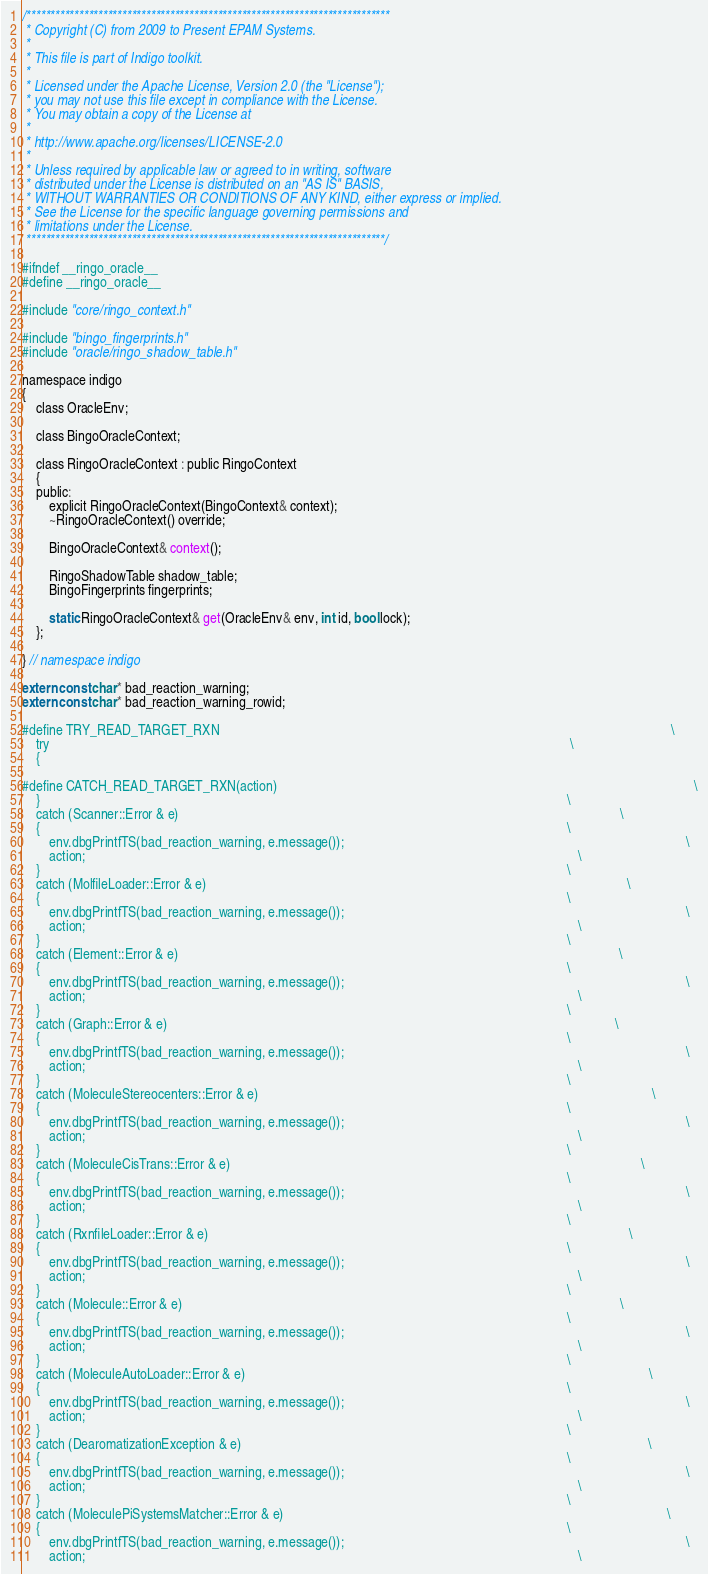<code> <loc_0><loc_0><loc_500><loc_500><_C_>/****************************************************************************
 * Copyright (C) from 2009 to Present EPAM Systems.
 *
 * This file is part of Indigo toolkit.
 *
 * Licensed under the Apache License, Version 2.0 (the "License");
 * you may not use this file except in compliance with the License.
 * You may obtain a copy of the License at
 *
 * http://www.apache.org/licenses/LICENSE-2.0
 *
 * Unless required by applicable law or agreed to in writing, software
 * distributed under the License is distributed on an "AS IS" BASIS,
 * WITHOUT WARRANTIES OR CONDITIONS OF ANY KIND, either express or implied.
 * See the License for the specific language governing permissions and
 * limitations under the License.
 ***************************************************************************/

#ifndef __ringo_oracle__
#define __ringo_oracle__

#include "core/ringo_context.h"

#include "bingo_fingerprints.h"
#include "oracle/ringo_shadow_table.h"

namespace indigo
{
    class OracleEnv;

    class BingoOracleContext;

    class RingoOracleContext : public RingoContext
    {
    public:
        explicit RingoOracleContext(BingoContext& context);
        ~RingoOracleContext() override;

        BingoOracleContext& context();

        RingoShadowTable shadow_table;
        BingoFingerprints fingerprints;

        static RingoOracleContext& get(OracleEnv& env, int id, bool lock);
    };

} // namespace indigo

extern const char* bad_reaction_warning;
extern const char* bad_reaction_warning_rowid;

#define TRY_READ_TARGET_RXN                                                                                                                                    \
    try                                                                                                                                                        \
    {

#define CATCH_READ_TARGET_RXN(action)                                                                                                                          \
    }                                                                                                                                                          \
    catch (Scanner::Error & e)                                                                                                                                 \
    {                                                                                                                                                          \
        env.dbgPrintfTS(bad_reaction_warning, e.message());                                                                                                    \
        action;                                                                                                                                                \
    }                                                                                                                                                          \
    catch (MolfileLoader::Error & e)                                                                                                                           \
    {                                                                                                                                                          \
        env.dbgPrintfTS(bad_reaction_warning, e.message());                                                                                                    \
        action;                                                                                                                                                \
    }                                                                                                                                                          \
    catch (Element::Error & e)                                                                                                                                 \
    {                                                                                                                                                          \
        env.dbgPrintfTS(bad_reaction_warning, e.message());                                                                                                    \
        action;                                                                                                                                                \
    }                                                                                                                                                          \
    catch (Graph::Error & e)                                                                                                                                   \
    {                                                                                                                                                          \
        env.dbgPrintfTS(bad_reaction_warning, e.message());                                                                                                    \
        action;                                                                                                                                                \
    }                                                                                                                                                          \
    catch (MoleculeStereocenters::Error & e)                                                                                                                   \
    {                                                                                                                                                          \
        env.dbgPrintfTS(bad_reaction_warning, e.message());                                                                                                    \
        action;                                                                                                                                                \
    }                                                                                                                                                          \
    catch (MoleculeCisTrans::Error & e)                                                                                                                        \
    {                                                                                                                                                          \
        env.dbgPrintfTS(bad_reaction_warning, e.message());                                                                                                    \
        action;                                                                                                                                                \
    }                                                                                                                                                          \
    catch (RxnfileLoader::Error & e)                                                                                                                           \
    {                                                                                                                                                          \
        env.dbgPrintfTS(bad_reaction_warning, e.message());                                                                                                    \
        action;                                                                                                                                                \
    }                                                                                                                                                          \
    catch (Molecule::Error & e)                                                                                                                                \
    {                                                                                                                                                          \
        env.dbgPrintfTS(bad_reaction_warning, e.message());                                                                                                    \
        action;                                                                                                                                                \
    }                                                                                                                                                          \
    catch (MoleculeAutoLoader::Error & e)                                                                                                                      \
    {                                                                                                                                                          \
        env.dbgPrintfTS(bad_reaction_warning, e.message());                                                                                                    \
        action;                                                                                                                                                \
    }                                                                                                                                                          \
    catch (DearomatizationException & e)                                                                                                                       \
    {                                                                                                                                                          \
        env.dbgPrintfTS(bad_reaction_warning, e.message());                                                                                                    \
        action;                                                                                                                                                \
    }                                                                                                                                                          \
    catch (MoleculePiSystemsMatcher::Error & e)                                                                                                                \
    {                                                                                                                                                          \
        env.dbgPrintfTS(bad_reaction_warning, e.message());                                                                                                    \
        action;                                                                                                                                                \</code> 